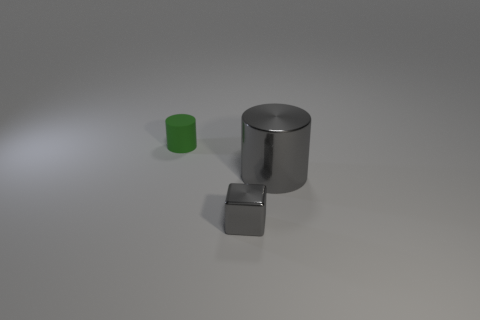Add 2 large green rubber balls. How many objects exist? 5 Subtract all cylinders. How many objects are left? 1 Subtract 1 cubes. How many cubes are left? 0 Subtract 0 blue cylinders. How many objects are left? 3 Subtract all purple blocks. Subtract all red cylinders. How many blocks are left? 1 Subtract all large red rubber things. Subtract all tiny gray metal objects. How many objects are left? 2 Add 2 large metal objects. How many large metal objects are left? 3 Add 3 brown rubber cubes. How many brown rubber cubes exist? 3 